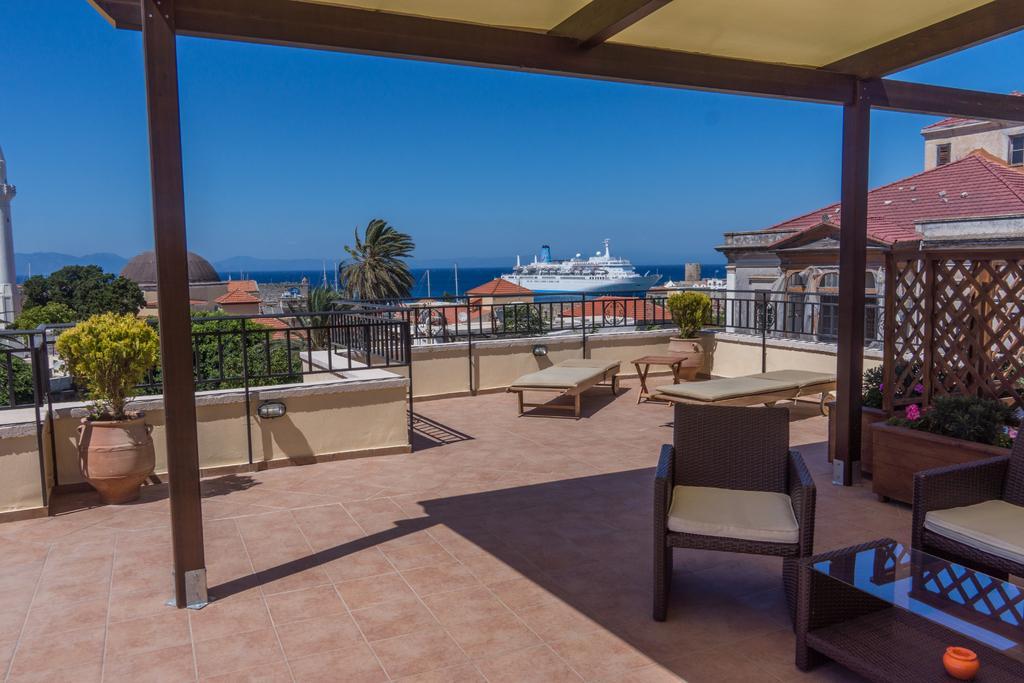Could you give a brief overview of what you see in this image? In this image at the left side there is a pot having plant in it at the backside of it there are few trees and building. At the middle of the image there is a ship, houses and few trees. At the right side there is a house before it there are pots having plants in it. At the right side there are two chairs before a table. There are two beds in between there is a table and back to it there is a pot having plant in it. 